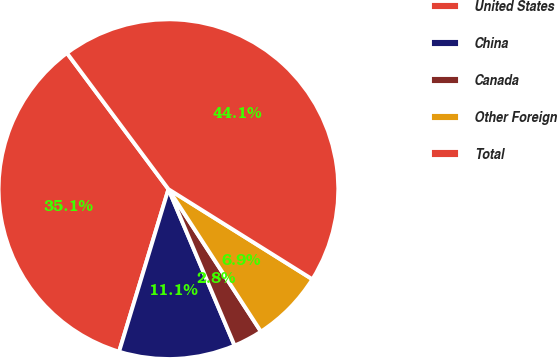Convert chart to OTSL. <chart><loc_0><loc_0><loc_500><loc_500><pie_chart><fcel>United States<fcel>China<fcel>Canada<fcel>Other Foreign<fcel>Total<nl><fcel>35.11%<fcel>11.06%<fcel>2.8%<fcel>6.93%<fcel>44.1%<nl></chart> 